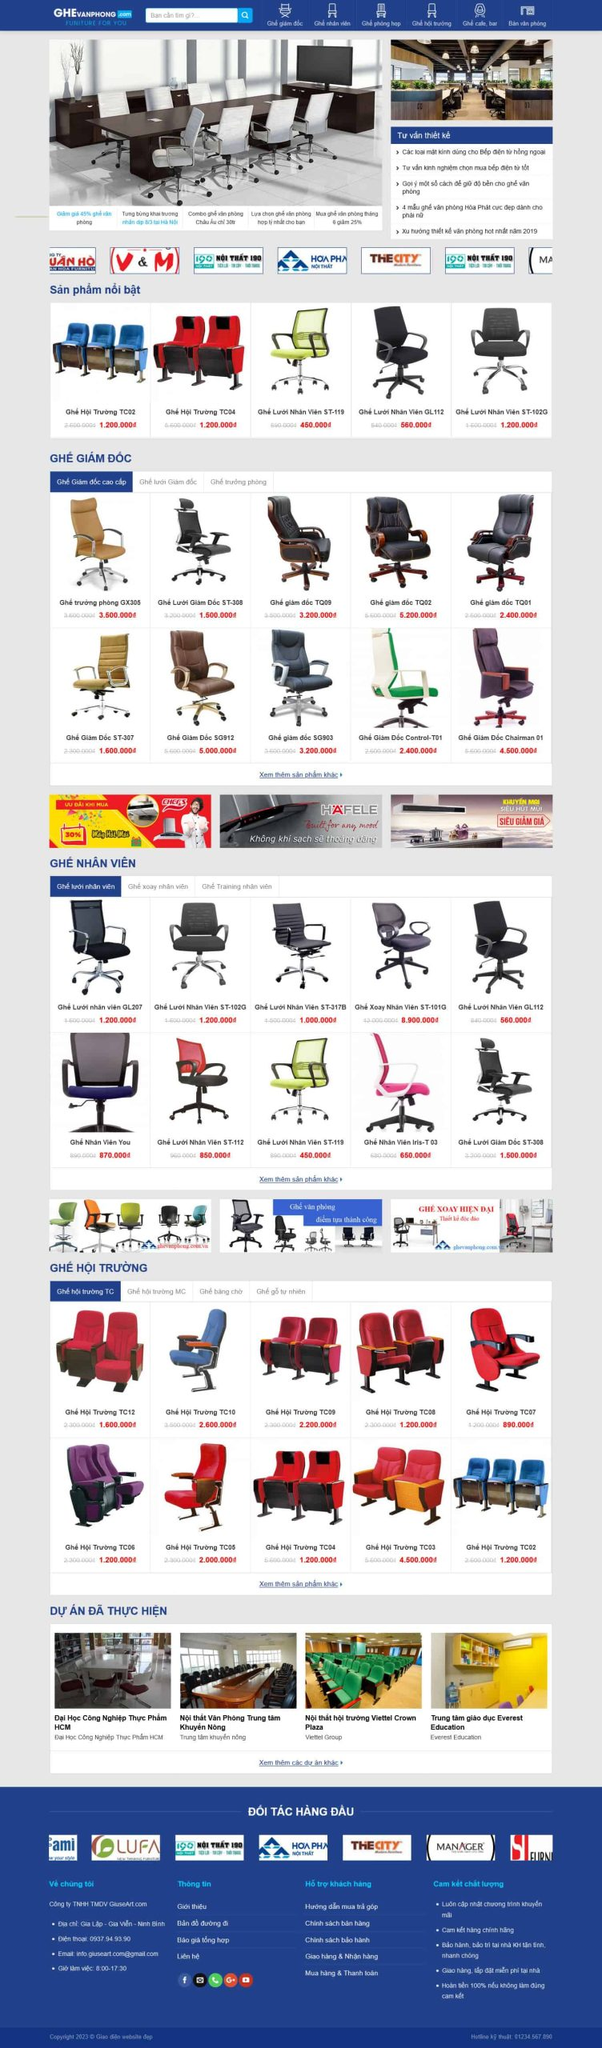Liệt kê 5 ngành nghề, lĩnh vực phù hợp với website này, phân cách các màu sắc bằng dấu phẩy. Chỉ trả về kết quả, phân cách bằng dấy phẩy
 Nội thất văn phòng, Nội thất hội trường, Nội thất trường học, Nội thất công cộng, Thiết kế nội thất 